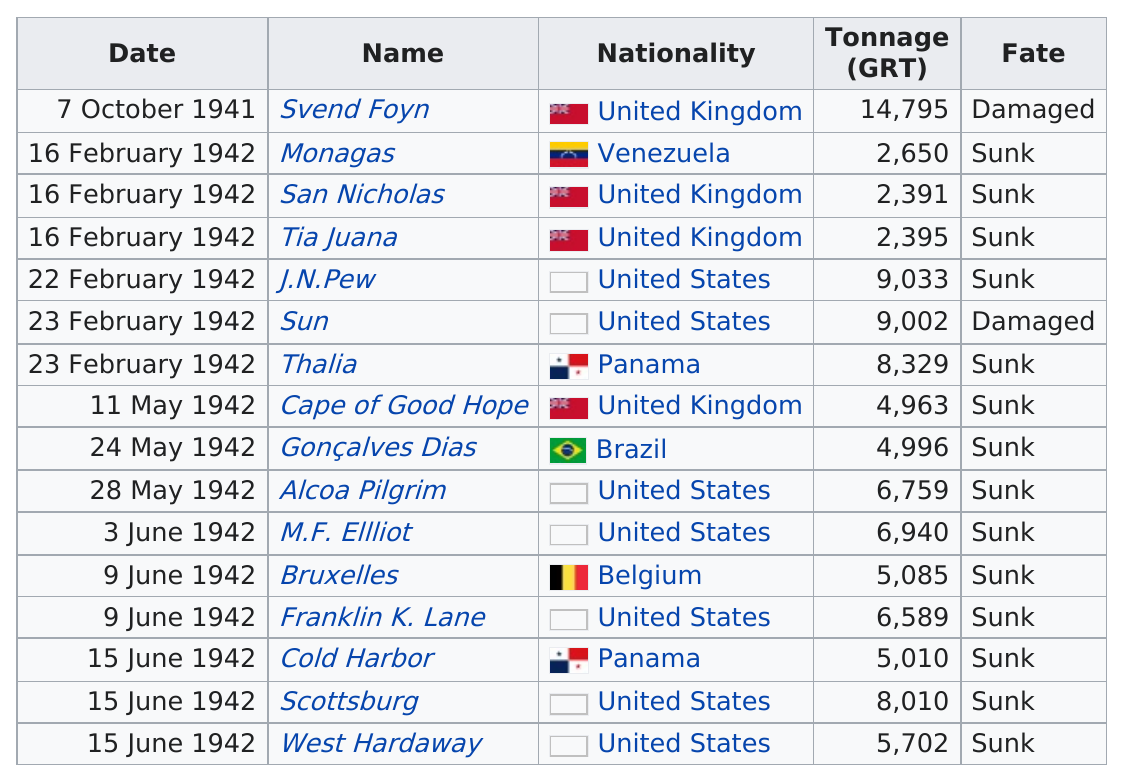Mention a couple of crucial points in this snapshot. The United States lost the most ships to U-502. The submarine named Monagas was the only one from Venezuela. Of the countries that had at least 10,000 tons of total shipping sunk, three had more than that amount. After 1941, it is estimated that three United Kingdom ships were sunk. The last submarine was on June 15th, 1942. 